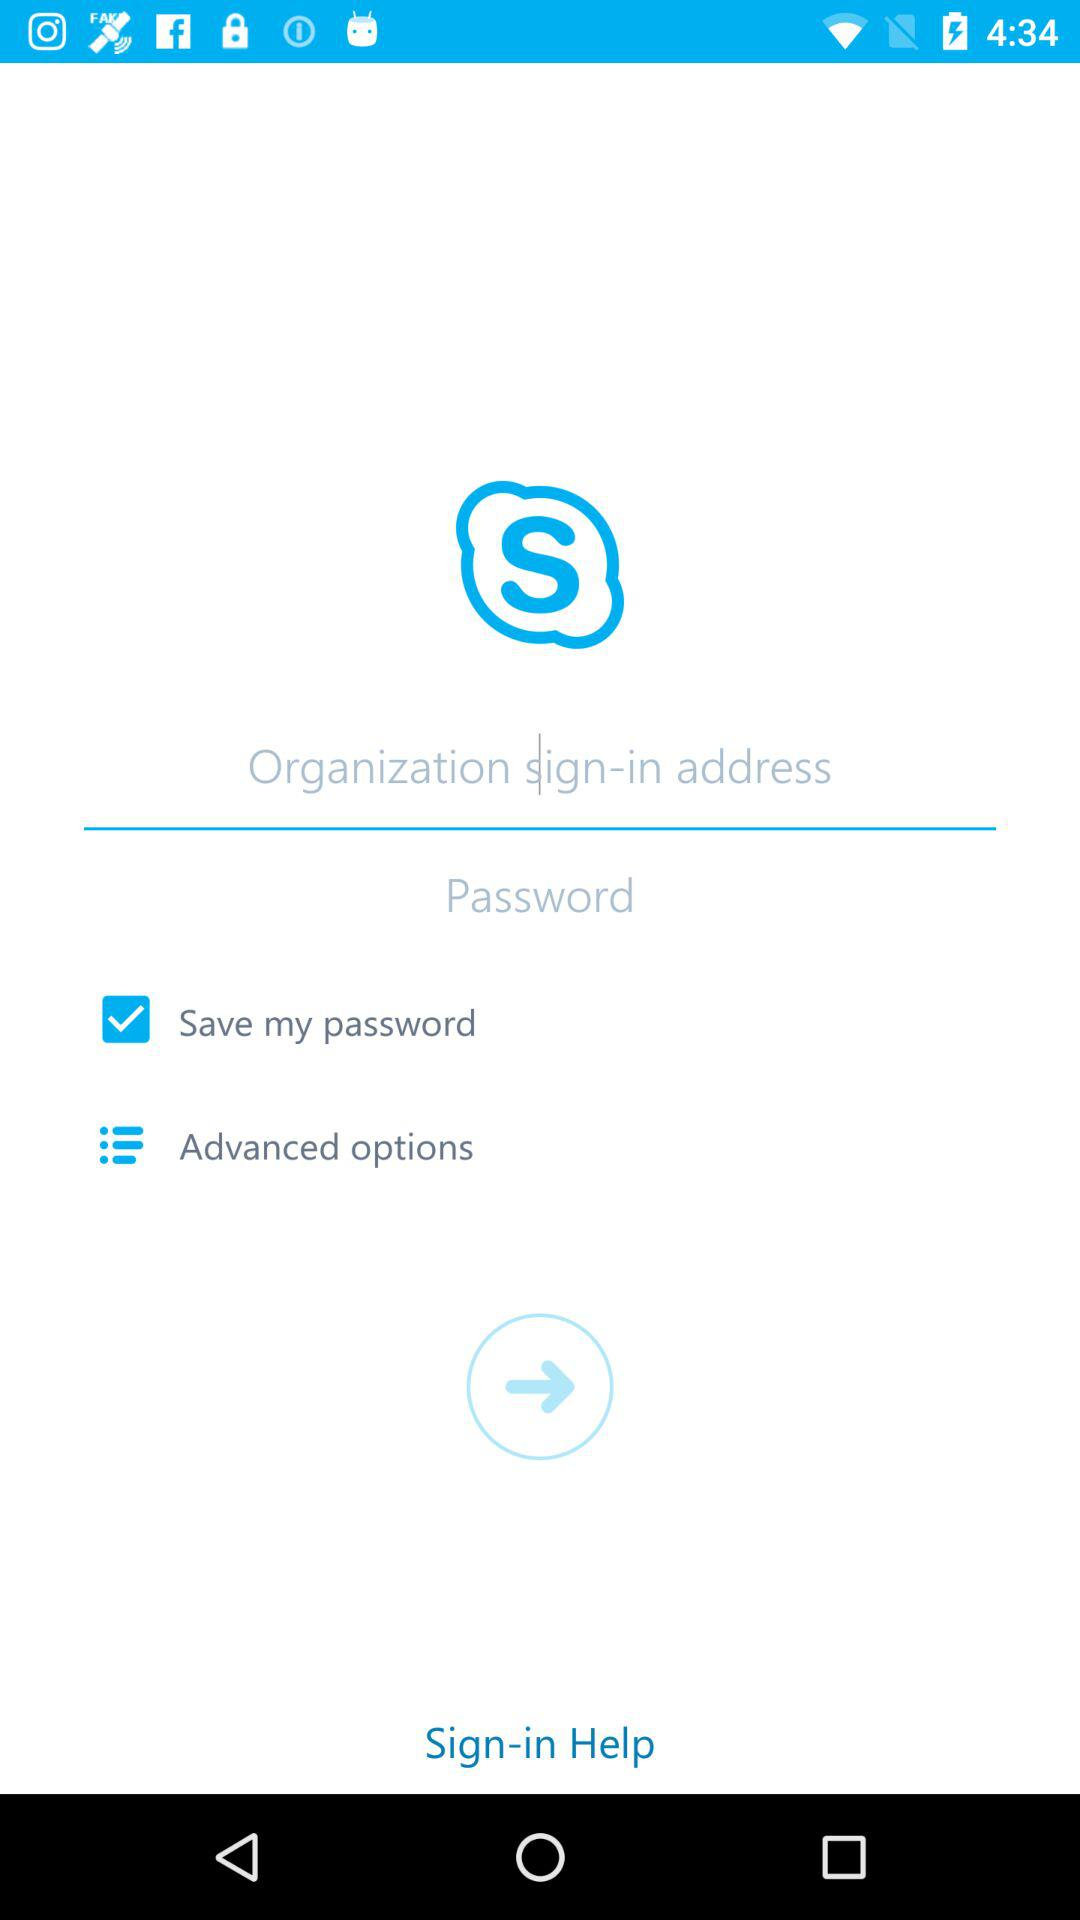What is the application name? The name of the application is "Skype". 